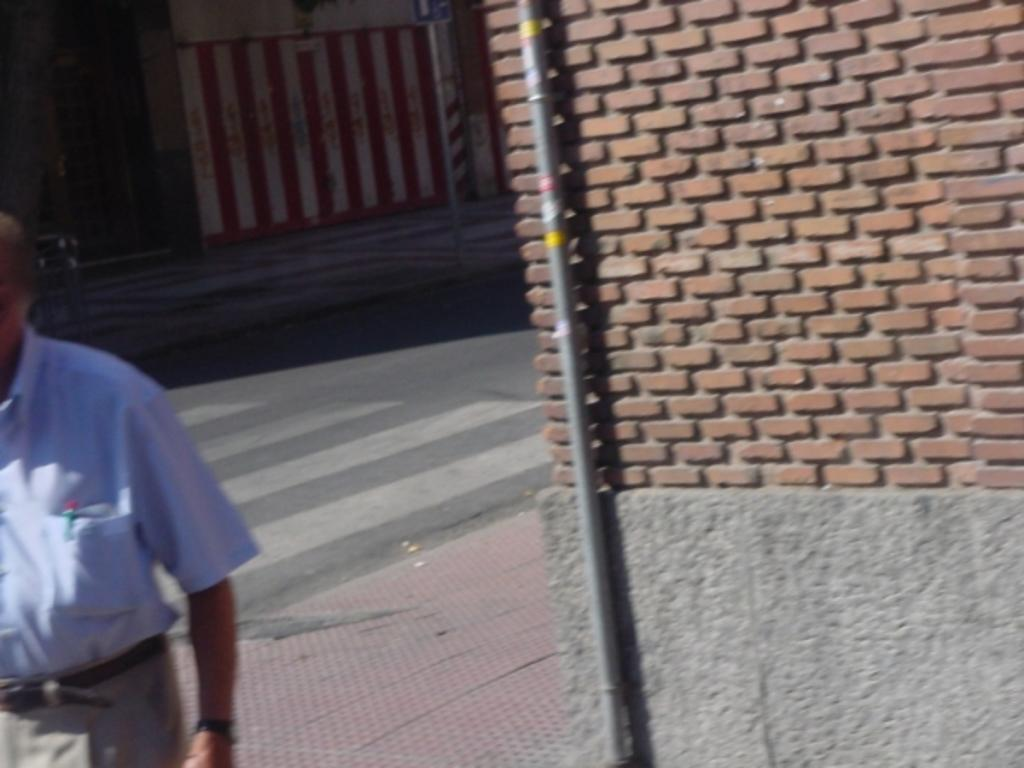What is the main subject of the image? There is a person in the image. What can be seen in the background of the image? There is a wall in the background of the image. What type of infrastructure is present in the image? There is a road and poles in the image. How many jellyfish are swimming in the image? There are no jellyfish present in the image. Is the person in the image being attacked by any creatures? There is no indication of an attack or any creatures in the image. 